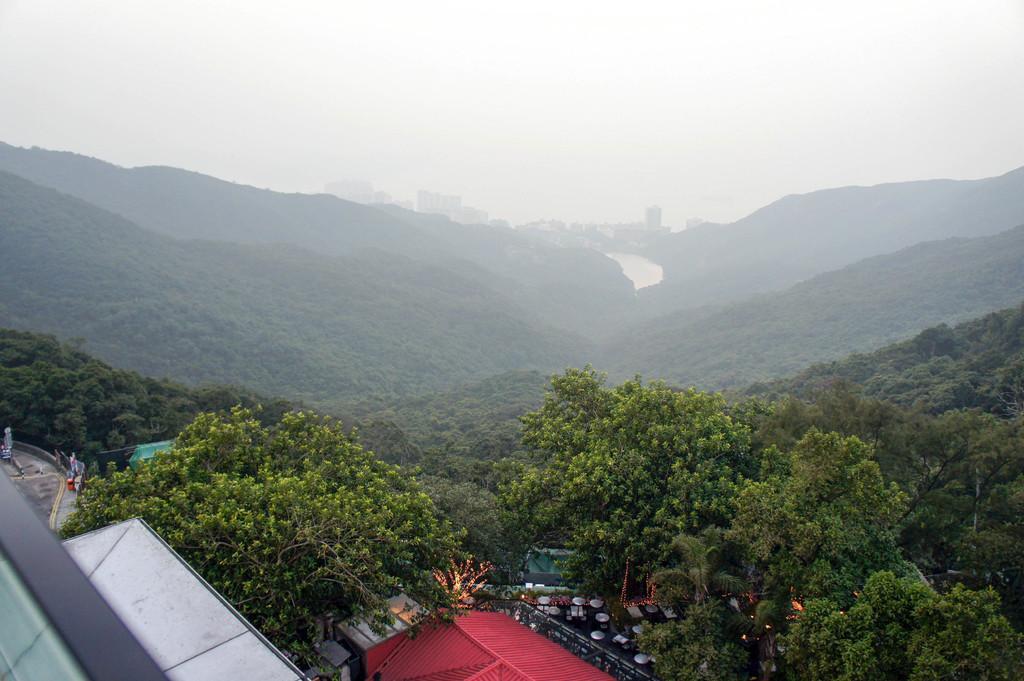Please provide a concise description of this image. This picture shows few trees and we see buildings and hills and a cloudy Sky. 